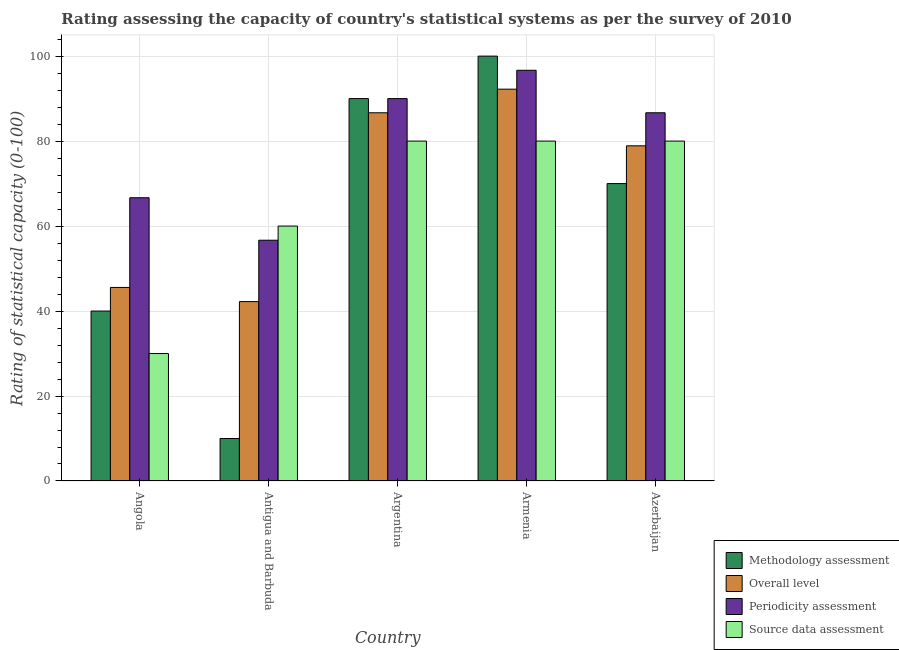How many different coloured bars are there?
Your response must be concise. 4. How many groups of bars are there?
Ensure brevity in your answer.  5. Are the number of bars per tick equal to the number of legend labels?
Offer a terse response. Yes. Are the number of bars on each tick of the X-axis equal?
Your response must be concise. Yes. How many bars are there on the 5th tick from the right?
Offer a terse response. 4. What is the label of the 1st group of bars from the left?
Provide a short and direct response. Angola. What is the overall level rating in Antigua and Barbuda?
Offer a very short reply. 42.22. Across all countries, what is the maximum overall level rating?
Your answer should be very brief. 92.22. Across all countries, what is the minimum source data assessment rating?
Give a very brief answer. 30. In which country was the overall level rating maximum?
Your answer should be compact. Armenia. In which country was the methodology assessment rating minimum?
Offer a terse response. Antigua and Barbuda. What is the total overall level rating in the graph?
Your answer should be compact. 345.56. What is the difference between the periodicity assessment rating in Antigua and Barbuda and that in Argentina?
Provide a succinct answer. -33.33. What is the difference between the overall level rating in Argentina and the methodology assessment rating in Armenia?
Keep it short and to the point. -13.33. What is the difference between the methodology assessment rating and periodicity assessment rating in Armenia?
Keep it short and to the point. 3.33. In how many countries, is the methodology assessment rating greater than 72 ?
Your answer should be very brief. 2. What is the ratio of the periodicity assessment rating in Angola to that in Armenia?
Ensure brevity in your answer.  0.69. What is the difference between the highest and the lowest periodicity assessment rating?
Your answer should be very brief. 40. In how many countries, is the overall level rating greater than the average overall level rating taken over all countries?
Your answer should be very brief. 3. What does the 4th bar from the left in Armenia represents?
Ensure brevity in your answer.  Source data assessment. What does the 3rd bar from the right in Azerbaijan represents?
Ensure brevity in your answer.  Overall level. How many countries are there in the graph?
Offer a terse response. 5. What is the difference between two consecutive major ticks on the Y-axis?
Your answer should be very brief. 20. Does the graph contain grids?
Your answer should be very brief. Yes. Where does the legend appear in the graph?
Give a very brief answer. Bottom right. How many legend labels are there?
Offer a terse response. 4. What is the title of the graph?
Keep it short and to the point. Rating assessing the capacity of country's statistical systems as per the survey of 2010 . What is the label or title of the X-axis?
Offer a very short reply. Country. What is the label or title of the Y-axis?
Offer a very short reply. Rating of statistical capacity (0-100). What is the Rating of statistical capacity (0-100) of Overall level in Angola?
Offer a very short reply. 45.56. What is the Rating of statistical capacity (0-100) in Periodicity assessment in Angola?
Give a very brief answer. 66.67. What is the Rating of statistical capacity (0-100) of Source data assessment in Angola?
Ensure brevity in your answer.  30. What is the Rating of statistical capacity (0-100) in Overall level in Antigua and Barbuda?
Make the answer very short. 42.22. What is the Rating of statistical capacity (0-100) of Periodicity assessment in Antigua and Barbuda?
Ensure brevity in your answer.  56.67. What is the Rating of statistical capacity (0-100) of Source data assessment in Antigua and Barbuda?
Offer a terse response. 60. What is the Rating of statistical capacity (0-100) of Methodology assessment in Argentina?
Your answer should be compact. 90. What is the Rating of statistical capacity (0-100) in Overall level in Argentina?
Make the answer very short. 86.67. What is the Rating of statistical capacity (0-100) of Periodicity assessment in Argentina?
Keep it short and to the point. 90. What is the Rating of statistical capacity (0-100) in Source data assessment in Argentina?
Provide a succinct answer. 80. What is the Rating of statistical capacity (0-100) in Methodology assessment in Armenia?
Your answer should be compact. 100. What is the Rating of statistical capacity (0-100) of Overall level in Armenia?
Offer a terse response. 92.22. What is the Rating of statistical capacity (0-100) in Periodicity assessment in Armenia?
Provide a short and direct response. 96.67. What is the Rating of statistical capacity (0-100) in Source data assessment in Armenia?
Give a very brief answer. 80. What is the Rating of statistical capacity (0-100) of Methodology assessment in Azerbaijan?
Offer a terse response. 70. What is the Rating of statistical capacity (0-100) in Overall level in Azerbaijan?
Your answer should be compact. 78.89. What is the Rating of statistical capacity (0-100) of Periodicity assessment in Azerbaijan?
Your response must be concise. 86.67. What is the Rating of statistical capacity (0-100) of Source data assessment in Azerbaijan?
Your answer should be compact. 80. Across all countries, what is the maximum Rating of statistical capacity (0-100) in Overall level?
Provide a short and direct response. 92.22. Across all countries, what is the maximum Rating of statistical capacity (0-100) in Periodicity assessment?
Make the answer very short. 96.67. Across all countries, what is the minimum Rating of statistical capacity (0-100) in Methodology assessment?
Give a very brief answer. 10. Across all countries, what is the minimum Rating of statistical capacity (0-100) in Overall level?
Your answer should be compact. 42.22. Across all countries, what is the minimum Rating of statistical capacity (0-100) of Periodicity assessment?
Make the answer very short. 56.67. Across all countries, what is the minimum Rating of statistical capacity (0-100) of Source data assessment?
Offer a terse response. 30. What is the total Rating of statistical capacity (0-100) in Methodology assessment in the graph?
Provide a short and direct response. 310. What is the total Rating of statistical capacity (0-100) of Overall level in the graph?
Make the answer very short. 345.56. What is the total Rating of statistical capacity (0-100) of Periodicity assessment in the graph?
Give a very brief answer. 396.67. What is the total Rating of statistical capacity (0-100) of Source data assessment in the graph?
Provide a short and direct response. 330. What is the difference between the Rating of statistical capacity (0-100) in Overall level in Angola and that in Antigua and Barbuda?
Your answer should be compact. 3.33. What is the difference between the Rating of statistical capacity (0-100) in Periodicity assessment in Angola and that in Antigua and Barbuda?
Give a very brief answer. 10. What is the difference between the Rating of statistical capacity (0-100) in Source data assessment in Angola and that in Antigua and Barbuda?
Provide a short and direct response. -30. What is the difference between the Rating of statistical capacity (0-100) of Overall level in Angola and that in Argentina?
Your answer should be compact. -41.11. What is the difference between the Rating of statistical capacity (0-100) of Periodicity assessment in Angola and that in Argentina?
Keep it short and to the point. -23.33. What is the difference between the Rating of statistical capacity (0-100) in Methodology assessment in Angola and that in Armenia?
Your response must be concise. -60. What is the difference between the Rating of statistical capacity (0-100) of Overall level in Angola and that in Armenia?
Ensure brevity in your answer.  -46.67. What is the difference between the Rating of statistical capacity (0-100) in Periodicity assessment in Angola and that in Armenia?
Make the answer very short. -30. What is the difference between the Rating of statistical capacity (0-100) in Source data assessment in Angola and that in Armenia?
Ensure brevity in your answer.  -50. What is the difference between the Rating of statistical capacity (0-100) of Methodology assessment in Angola and that in Azerbaijan?
Keep it short and to the point. -30. What is the difference between the Rating of statistical capacity (0-100) of Overall level in Angola and that in Azerbaijan?
Ensure brevity in your answer.  -33.33. What is the difference between the Rating of statistical capacity (0-100) in Methodology assessment in Antigua and Barbuda and that in Argentina?
Ensure brevity in your answer.  -80. What is the difference between the Rating of statistical capacity (0-100) of Overall level in Antigua and Barbuda and that in Argentina?
Give a very brief answer. -44.44. What is the difference between the Rating of statistical capacity (0-100) in Periodicity assessment in Antigua and Barbuda and that in Argentina?
Your answer should be compact. -33.33. What is the difference between the Rating of statistical capacity (0-100) of Methodology assessment in Antigua and Barbuda and that in Armenia?
Ensure brevity in your answer.  -90. What is the difference between the Rating of statistical capacity (0-100) of Overall level in Antigua and Barbuda and that in Armenia?
Provide a short and direct response. -50. What is the difference between the Rating of statistical capacity (0-100) of Periodicity assessment in Antigua and Barbuda and that in Armenia?
Offer a very short reply. -40. What is the difference between the Rating of statistical capacity (0-100) in Source data assessment in Antigua and Barbuda and that in Armenia?
Make the answer very short. -20. What is the difference between the Rating of statistical capacity (0-100) in Methodology assessment in Antigua and Barbuda and that in Azerbaijan?
Give a very brief answer. -60. What is the difference between the Rating of statistical capacity (0-100) of Overall level in Antigua and Barbuda and that in Azerbaijan?
Your answer should be compact. -36.67. What is the difference between the Rating of statistical capacity (0-100) of Source data assessment in Antigua and Barbuda and that in Azerbaijan?
Ensure brevity in your answer.  -20. What is the difference between the Rating of statistical capacity (0-100) of Overall level in Argentina and that in Armenia?
Your answer should be compact. -5.56. What is the difference between the Rating of statistical capacity (0-100) of Periodicity assessment in Argentina and that in Armenia?
Give a very brief answer. -6.67. What is the difference between the Rating of statistical capacity (0-100) in Methodology assessment in Argentina and that in Azerbaijan?
Your answer should be compact. 20. What is the difference between the Rating of statistical capacity (0-100) of Overall level in Argentina and that in Azerbaijan?
Give a very brief answer. 7.78. What is the difference between the Rating of statistical capacity (0-100) of Source data assessment in Argentina and that in Azerbaijan?
Provide a succinct answer. 0. What is the difference between the Rating of statistical capacity (0-100) in Methodology assessment in Armenia and that in Azerbaijan?
Offer a very short reply. 30. What is the difference between the Rating of statistical capacity (0-100) in Overall level in Armenia and that in Azerbaijan?
Your response must be concise. 13.33. What is the difference between the Rating of statistical capacity (0-100) of Periodicity assessment in Armenia and that in Azerbaijan?
Your answer should be compact. 10. What is the difference between the Rating of statistical capacity (0-100) of Methodology assessment in Angola and the Rating of statistical capacity (0-100) of Overall level in Antigua and Barbuda?
Offer a terse response. -2.22. What is the difference between the Rating of statistical capacity (0-100) in Methodology assessment in Angola and the Rating of statistical capacity (0-100) in Periodicity assessment in Antigua and Barbuda?
Your response must be concise. -16.67. What is the difference between the Rating of statistical capacity (0-100) in Overall level in Angola and the Rating of statistical capacity (0-100) in Periodicity assessment in Antigua and Barbuda?
Offer a very short reply. -11.11. What is the difference between the Rating of statistical capacity (0-100) of Overall level in Angola and the Rating of statistical capacity (0-100) of Source data assessment in Antigua and Barbuda?
Ensure brevity in your answer.  -14.44. What is the difference between the Rating of statistical capacity (0-100) of Methodology assessment in Angola and the Rating of statistical capacity (0-100) of Overall level in Argentina?
Provide a short and direct response. -46.67. What is the difference between the Rating of statistical capacity (0-100) in Methodology assessment in Angola and the Rating of statistical capacity (0-100) in Periodicity assessment in Argentina?
Keep it short and to the point. -50. What is the difference between the Rating of statistical capacity (0-100) of Overall level in Angola and the Rating of statistical capacity (0-100) of Periodicity assessment in Argentina?
Your answer should be compact. -44.44. What is the difference between the Rating of statistical capacity (0-100) of Overall level in Angola and the Rating of statistical capacity (0-100) of Source data assessment in Argentina?
Offer a very short reply. -34.44. What is the difference between the Rating of statistical capacity (0-100) of Periodicity assessment in Angola and the Rating of statistical capacity (0-100) of Source data assessment in Argentina?
Your answer should be compact. -13.33. What is the difference between the Rating of statistical capacity (0-100) of Methodology assessment in Angola and the Rating of statistical capacity (0-100) of Overall level in Armenia?
Your answer should be very brief. -52.22. What is the difference between the Rating of statistical capacity (0-100) of Methodology assessment in Angola and the Rating of statistical capacity (0-100) of Periodicity assessment in Armenia?
Your response must be concise. -56.67. What is the difference between the Rating of statistical capacity (0-100) in Methodology assessment in Angola and the Rating of statistical capacity (0-100) in Source data assessment in Armenia?
Provide a short and direct response. -40. What is the difference between the Rating of statistical capacity (0-100) in Overall level in Angola and the Rating of statistical capacity (0-100) in Periodicity assessment in Armenia?
Offer a very short reply. -51.11. What is the difference between the Rating of statistical capacity (0-100) of Overall level in Angola and the Rating of statistical capacity (0-100) of Source data assessment in Armenia?
Ensure brevity in your answer.  -34.44. What is the difference between the Rating of statistical capacity (0-100) in Periodicity assessment in Angola and the Rating of statistical capacity (0-100) in Source data assessment in Armenia?
Provide a short and direct response. -13.33. What is the difference between the Rating of statistical capacity (0-100) of Methodology assessment in Angola and the Rating of statistical capacity (0-100) of Overall level in Azerbaijan?
Offer a very short reply. -38.89. What is the difference between the Rating of statistical capacity (0-100) of Methodology assessment in Angola and the Rating of statistical capacity (0-100) of Periodicity assessment in Azerbaijan?
Offer a very short reply. -46.67. What is the difference between the Rating of statistical capacity (0-100) in Overall level in Angola and the Rating of statistical capacity (0-100) in Periodicity assessment in Azerbaijan?
Your answer should be compact. -41.11. What is the difference between the Rating of statistical capacity (0-100) in Overall level in Angola and the Rating of statistical capacity (0-100) in Source data assessment in Azerbaijan?
Give a very brief answer. -34.44. What is the difference between the Rating of statistical capacity (0-100) in Periodicity assessment in Angola and the Rating of statistical capacity (0-100) in Source data assessment in Azerbaijan?
Your answer should be compact. -13.33. What is the difference between the Rating of statistical capacity (0-100) of Methodology assessment in Antigua and Barbuda and the Rating of statistical capacity (0-100) of Overall level in Argentina?
Offer a very short reply. -76.67. What is the difference between the Rating of statistical capacity (0-100) in Methodology assessment in Antigua and Barbuda and the Rating of statistical capacity (0-100) in Periodicity assessment in Argentina?
Your answer should be very brief. -80. What is the difference between the Rating of statistical capacity (0-100) in Methodology assessment in Antigua and Barbuda and the Rating of statistical capacity (0-100) in Source data assessment in Argentina?
Provide a short and direct response. -70. What is the difference between the Rating of statistical capacity (0-100) in Overall level in Antigua and Barbuda and the Rating of statistical capacity (0-100) in Periodicity assessment in Argentina?
Offer a very short reply. -47.78. What is the difference between the Rating of statistical capacity (0-100) in Overall level in Antigua and Barbuda and the Rating of statistical capacity (0-100) in Source data assessment in Argentina?
Provide a short and direct response. -37.78. What is the difference between the Rating of statistical capacity (0-100) in Periodicity assessment in Antigua and Barbuda and the Rating of statistical capacity (0-100) in Source data assessment in Argentina?
Provide a succinct answer. -23.33. What is the difference between the Rating of statistical capacity (0-100) in Methodology assessment in Antigua and Barbuda and the Rating of statistical capacity (0-100) in Overall level in Armenia?
Your response must be concise. -82.22. What is the difference between the Rating of statistical capacity (0-100) of Methodology assessment in Antigua and Barbuda and the Rating of statistical capacity (0-100) of Periodicity assessment in Armenia?
Provide a succinct answer. -86.67. What is the difference between the Rating of statistical capacity (0-100) of Methodology assessment in Antigua and Barbuda and the Rating of statistical capacity (0-100) of Source data assessment in Armenia?
Your answer should be very brief. -70. What is the difference between the Rating of statistical capacity (0-100) in Overall level in Antigua and Barbuda and the Rating of statistical capacity (0-100) in Periodicity assessment in Armenia?
Offer a terse response. -54.44. What is the difference between the Rating of statistical capacity (0-100) of Overall level in Antigua and Barbuda and the Rating of statistical capacity (0-100) of Source data assessment in Armenia?
Provide a short and direct response. -37.78. What is the difference between the Rating of statistical capacity (0-100) of Periodicity assessment in Antigua and Barbuda and the Rating of statistical capacity (0-100) of Source data assessment in Armenia?
Ensure brevity in your answer.  -23.33. What is the difference between the Rating of statistical capacity (0-100) of Methodology assessment in Antigua and Barbuda and the Rating of statistical capacity (0-100) of Overall level in Azerbaijan?
Offer a terse response. -68.89. What is the difference between the Rating of statistical capacity (0-100) of Methodology assessment in Antigua and Barbuda and the Rating of statistical capacity (0-100) of Periodicity assessment in Azerbaijan?
Make the answer very short. -76.67. What is the difference between the Rating of statistical capacity (0-100) of Methodology assessment in Antigua and Barbuda and the Rating of statistical capacity (0-100) of Source data assessment in Azerbaijan?
Make the answer very short. -70. What is the difference between the Rating of statistical capacity (0-100) of Overall level in Antigua and Barbuda and the Rating of statistical capacity (0-100) of Periodicity assessment in Azerbaijan?
Make the answer very short. -44.44. What is the difference between the Rating of statistical capacity (0-100) in Overall level in Antigua and Barbuda and the Rating of statistical capacity (0-100) in Source data assessment in Azerbaijan?
Offer a very short reply. -37.78. What is the difference between the Rating of statistical capacity (0-100) in Periodicity assessment in Antigua and Barbuda and the Rating of statistical capacity (0-100) in Source data assessment in Azerbaijan?
Keep it short and to the point. -23.33. What is the difference between the Rating of statistical capacity (0-100) in Methodology assessment in Argentina and the Rating of statistical capacity (0-100) in Overall level in Armenia?
Your response must be concise. -2.22. What is the difference between the Rating of statistical capacity (0-100) in Methodology assessment in Argentina and the Rating of statistical capacity (0-100) in Periodicity assessment in Armenia?
Offer a very short reply. -6.67. What is the difference between the Rating of statistical capacity (0-100) in Overall level in Argentina and the Rating of statistical capacity (0-100) in Source data assessment in Armenia?
Make the answer very short. 6.67. What is the difference between the Rating of statistical capacity (0-100) of Methodology assessment in Argentina and the Rating of statistical capacity (0-100) of Overall level in Azerbaijan?
Provide a short and direct response. 11.11. What is the difference between the Rating of statistical capacity (0-100) in Methodology assessment in Argentina and the Rating of statistical capacity (0-100) in Periodicity assessment in Azerbaijan?
Offer a terse response. 3.33. What is the difference between the Rating of statistical capacity (0-100) of Methodology assessment in Argentina and the Rating of statistical capacity (0-100) of Source data assessment in Azerbaijan?
Provide a short and direct response. 10. What is the difference between the Rating of statistical capacity (0-100) in Overall level in Argentina and the Rating of statistical capacity (0-100) in Source data assessment in Azerbaijan?
Give a very brief answer. 6.67. What is the difference between the Rating of statistical capacity (0-100) of Periodicity assessment in Argentina and the Rating of statistical capacity (0-100) of Source data assessment in Azerbaijan?
Give a very brief answer. 10. What is the difference between the Rating of statistical capacity (0-100) of Methodology assessment in Armenia and the Rating of statistical capacity (0-100) of Overall level in Azerbaijan?
Make the answer very short. 21.11. What is the difference between the Rating of statistical capacity (0-100) of Methodology assessment in Armenia and the Rating of statistical capacity (0-100) of Periodicity assessment in Azerbaijan?
Offer a terse response. 13.33. What is the difference between the Rating of statistical capacity (0-100) of Overall level in Armenia and the Rating of statistical capacity (0-100) of Periodicity assessment in Azerbaijan?
Provide a succinct answer. 5.56. What is the difference between the Rating of statistical capacity (0-100) in Overall level in Armenia and the Rating of statistical capacity (0-100) in Source data assessment in Azerbaijan?
Your answer should be very brief. 12.22. What is the difference between the Rating of statistical capacity (0-100) of Periodicity assessment in Armenia and the Rating of statistical capacity (0-100) of Source data assessment in Azerbaijan?
Offer a very short reply. 16.67. What is the average Rating of statistical capacity (0-100) of Methodology assessment per country?
Ensure brevity in your answer.  62. What is the average Rating of statistical capacity (0-100) of Overall level per country?
Your response must be concise. 69.11. What is the average Rating of statistical capacity (0-100) of Periodicity assessment per country?
Offer a terse response. 79.33. What is the difference between the Rating of statistical capacity (0-100) in Methodology assessment and Rating of statistical capacity (0-100) in Overall level in Angola?
Ensure brevity in your answer.  -5.56. What is the difference between the Rating of statistical capacity (0-100) of Methodology assessment and Rating of statistical capacity (0-100) of Periodicity assessment in Angola?
Your answer should be compact. -26.67. What is the difference between the Rating of statistical capacity (0-100) of Overall level and Rating of statistical capacity (0-100) of Periodicity assessment in Angola?
Give a very brief answer. -21.11. What is the difference between the Rating of statistical capacity (0-100) in Overall level and Rating of statistical capacity (0-100) in Source data assessment in Angola?
Your response must be concise. 15.56. What is the difference between the Rating of statistical capacity (0-100) in Periodicity assessment and Rating of statistical capacity (0-100) in Source data assessment in Angola?
Offer a terse response. 36.67. What is the difference between the Rating of statistical capacity (0-100) in Methodology assessment and Rating of statistical capacity (0-100) in Overall level in Antigua and Barbuda?
Your answer should be very brief. -32.22. What is the difference between the Rating of statistical capacity (0-100) of Methodology assessment and Rating of statistical capacity (0-100) of Periodicity assessment in Antigua and Barbuda?
Ensure brevity in your answer.  -46.67. What is the difference between the Rating of statistical capacity (0-100) of Methodology assessment and Rating of statistical capacity (0-100) of Source data assessment in Antigua and Barbuda?
Ensure brevity in your answer.  -50. What is the difference between the Rating of statistical capacity (0-100) in Overall level and Rating of statistical capacity (0-100) in Periodicity assessment in Antigua and Barbuda?
Give a very brief answer. -14.44. What is the difference between the Rating of statistical capacity (0-100) in Overall level and Rating of statistical capacity (0-100) in Source data assessment in Antigua and Barbuda?
Offer a very short reply. -17.78. What is the difference between the Rating of statistical capacity (0-100) in Periodicity assessment and Rating of statistical capacity (0-100) in Source data assessment in Antigua and Barbuda?
Your answer should be compact. -3.33. What is the difference between the Rating of statistical capacity (0-100) of Methodology assessment and Rating of statistical capacity (0-100) of Overall level in Argentina?
Provide a short and direct response. 3.33. What is the difference between the Rating of statistical capacity (0-100) of Overall level and Rating of statistical capacity (0-100) of Periodicity assessment in Argentina?
Make the answer very short. -3.33. What is the difference between the Rating of statistical capacity (0-100) in Overall level and Rating of statistical capacity (0-100) in Source data assessment in Argentina?
Your answer should be very brief. 6.67. What is the difference between the Rating of statistical capacity (0-100) of Periodicity assessment and Rating of statistical capacity (0-100) of Source data assessment in Argentina?
Provide a short and direct response. 10. What is the difference between the Rating of statistical capacity (0-100) in Methodology assessment and Rating of statistical capacity (0-100) in Overall level in Armenia?
Offer a terse response. 7.78. What is the difference between the Rating of statistical capacity (0-100) in Methodology assessment and Rating of statistical capacity (0-100) in Source data assessment in Armenia?
Provide a succinct answer. 20. What is the difference between the Rating of statistical capacity (0-100) in Overall level and Rating of statistical capacity (0-100) in Periodicity assessment in Armenia?
Give a very brief answer. -4.44. What is the difference between the Rating of statistical capacity (0-100) in Overall level and Rating of statistical capacity (0-100) in Source data assessment in Armenia?
Offer a very short reply. 12.22. What is the difference between the Rating of statistical capacity (0-100) in Periodicity assessment and Rating of statistical capacity (0-100) in Source data assessment in Armenia?
Give a very brief answer. 16.67. What is the difference between the Rating of statistical capacity (0-100) in Methodology assessment and Rating of statistical capacity (0-100) in Overall level in Azerbaijan?
Make the answer very short. -8.89. What is the difference between the Rating of statistical capacity (0-100) of Methodology assessment and Rating of statistical capacity (0-100) of Periodicity assessment in Azerbaijan?
Offer a very short reply. -16.67. What is the difference between the Rating of statistical capacity (0-100) of Methodology assessment and Rating of statistical capacity (0-100) of Source data assessment in Azerbaijan?
Offer a terse response. -10. What is the difference between the Rating of statistical capacity (0-100) of Overall level and Rating of statistical capacity (0-100) of Periodicity assessment in Azerbaijan?
Offer a very short reply. -7.78. What is the difference between the Rating of statistical capacity (0-100) in Overall level and Rating of statistical capacity (0-100) in Source data assessment in Azerbaijan?
Ensure brevity in your answer.  -1.11. What is the ratio of the Rating of statistical capacity (0-100) in Methodology assessment in Angola to that in Antigua and Barbuda?
Your answer should be compact. 4. What is the ratio of the Rating of statistical capacity (0-100) of Overall level in Angola to that in Antigua and Barbuda?
Offer a terse response. 1.08. What is the ratio of the Rating of statistical capacity (0-100) in Periodicity assessment in Angola to that in Antigua and Barbuda?
Your response must be concise. 1.18. What is the ratio of the Rating of statistical capacity (0-100) of Source data assessment in Angola to that in Antigua and Barbuda?
Provide a succinct answer. 0.5. What is the ratio of the Rating of statistical capacity (0-100) of Methodology assessment in Angola to that in Argentina?
Your answer should be compact. 0.44. What is the ratio of the Rating of statistical capacity (0-100) of Overall level in Angola to that in Argentina?
Give a very brief answer. 0.53. What is the ratio of the Rating of statistical capacity (0-100) of Periodicity assessment in Angola to that in Argentina?
Offer a terse response. 0.74. What is the ratio of the Rating of statistical capacity (0-100) of Source data assessment in Angola to that in Argentina?
Make the answer very short. 0.38. What is the ratio of the Rating of statistical capacity (0-100) in Methodology assessment in Angola to that in Armenia?
Your response must be concise. 0.4. What is the ratio of the Rating of statistical capacity (0-100) of Overall level in Angola to that in Armenia?
Make the answer very short. 0.49. What is the ratio of the Rating of statistical capacity (0-100) in Periodicity assessment in Angola to that in Armenia?
Your answer should be compact. 0.69. What is the ratio of the Rating of statistical capacity (0-100) of Overall level in Angola to that in Azerbaijan?
Your response must be concise. 0.58. What is the ratio of the Rating of statistical capacity (0-100) of Periodicity assessment in Angola to that in Azerbaijan?
Your answer should be compact. 0.77. What is the ratio of the Rating of statistical capacity (0-100) in Methodology assessment in Antigua and Barbuda to that in Argentina?
Provide a succinct answer. 0.11. What is the ratio of the Rating of statistical capacity (0-100) of Overall level in Antigua and Barbuda to that in Argentina?
Keep it short and to the point. 0.49. What is the ratio of the Rating of statistical capacity (0-100) of Periodicity assessment in Antigua and Barbuda to that in Argentina?
Provide a succinct answer. 0.63. What is the ratio of the Rating of statistical capacity (0-100) of Source data assessment in Antigua and Barbuda to that in Argentina?
Provide a short and direct response. 0.75. What is the ratio of the Rating of statistical capacity (0-100) in Overall level in Antigua and Barbuda to that in Armenia?
Make the answer very short. 0.46. What is the ratio of the Rating of statistical capacity (0-100) in Periodicity assessment in Antigua and Barbuda to that in Armenia?
Your response must be concise. 0.59. What is the ratio of the Rating of statistical capacity (0-100) in Source data assessment in Antigua and Barbuda to that in Armenia?
Provide a succinct answer. 0.75. What is the ratio of the Rating of statistical capacity (0-100) of Methodology assessment in Antigua and Barbuda to that in Azerbaijan?
Your answer should be compact. 0.14. What is the ratio of the Rating of statistical capacity (0-100) in Overall level in Antigua and Barbuda to that in Azerbaijan?
Offer a terse response. 0.54. What is the ratio of the Rating of statistical capacity (0-100) in Periodicity assessment in Antigua and Barbuda to that in Azerbaijan?
Offer a terse response. 0.65. What is the ratio of the Rating of statistical capacity (0-100) of Source data assessment in Antigua and Barbuda to that in Azerbaijan?
Your answer should be very brief. 0.75. What is the ratio of the Rating of statistical capacity (0-100) in Methodology assessment in Argentina to that in Armenia?
Provide a succinct answer. 0.9. What is the ratio of the Rating of statistical capacity (0-100) in Overall level in Argentina to that in Armenia?
Make the answer very short. 0.94. What is the ratio of the Rating of statistical capacity (0-100) in Methodology assessment in Argentina to that in Azerbaijan?
Ensure brevity in your answer.  1.29. What is the ratio of the Rating of statistical capacity (0-100) in Overall level in Argentina to that in Azerbaijan?
Your answer should be very brief. 1.1. What is the ratio of the Rating of statistical capacity (0-100) of Periodicity assessment in Argentina to that in Azerbaijan?
Offer a very short reply. 1.04. What is the ratio of the Rating of statistical capacity (0-100) of Methodology assessment in Armenia to that in Azerbaijan?
Your answer should be very brief. 1.43. What is the ratio of the Rating of statistical capacity (0-100) of Overall level in Armenia to that in Azerbaijan?
Offer a very short reply. 1.17. What is the ratio of the Rating of statistical capacity (0-100) of Periodicity assessment in Armenia to that in Azerbaijan?
Offer a very short reply. 1.12. What is the ratio of the Rating of statistical capacity (0-100) in Source data assessment in Armenia to that in Azerbaijan?
Your answer should be compact. 1. What is the difference between the highest and the second highest Rating of statistical capacity (0-100) of Overall level?
Your answer should be compact. 5.56. 